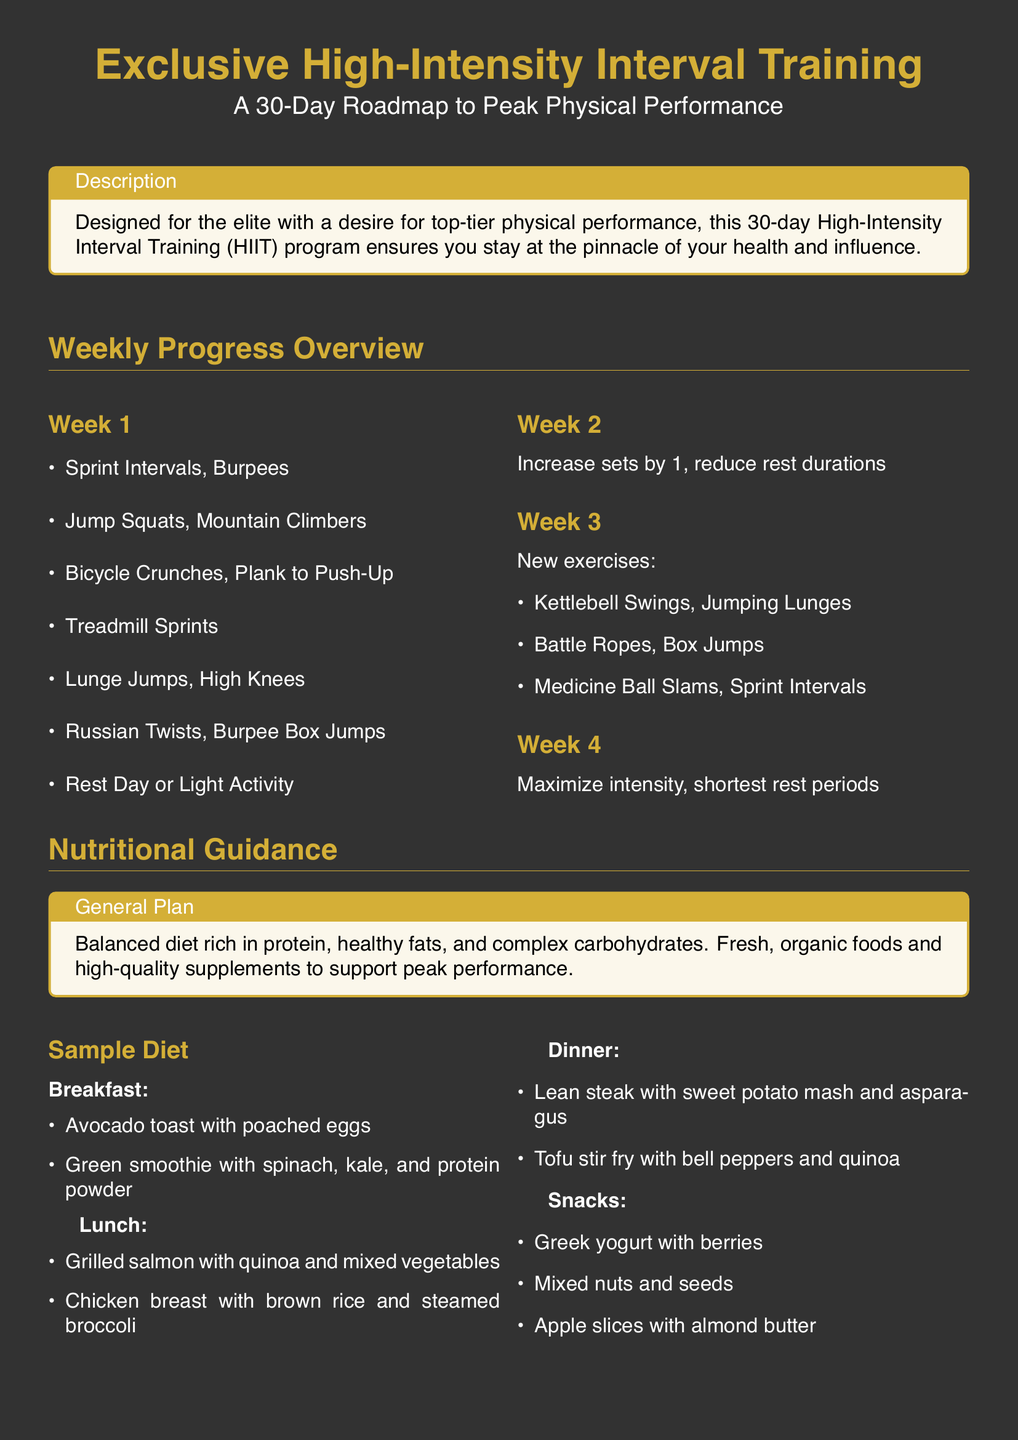What is the title of the program? The title of the program is prominently displayed at the beginning of the document, indicating its focus on high-intensity interval training.
Answer: Exclusive High-Intensity Interval Training How long is the program designed for? The document specifies the duration of the workout program in its introduction, indicating a clear timeframe for participants.
Answer: 30-Day What are the new exercises introduced in Week 3? The document lists specific new exercises included in Week 3 for variety and progression in the training program.
Answer: Kettlebell Swings, Jumping Lunges, Battle Ropes, Box Jumps, Medicine Ball Slams, Sprint Intervals How many liters of water should be consumed daily? The document includes advice on hydration, specifying the daily water intake necessary for optimal performance.
Answer: 3 liters What type of diet is recommended in the general plan? The nutritional guidance section of the document describes the overall dietary approach athletes should follow for peak performance.
Answer: Balanced diet rich in protein, healthy fats, and complex carbohydrates Which exercise appears on both Week 1 and Week 3 lists? The comparison of exercises in the weekly plans highlights repetitions and focuses within the program's structure.
Answer: Sprint Intervals What snack is suggested that includes yogurt? The document provides specific examples of snacks that align with the nutritional plan, including one that features yogurt as a primary ingredient.
Answer: Greek yogurt with berries What should be considered for tailoring the diet further? The document suggests a way for individuals to personalize their nutritional approach for better results.
Answer: Consulting a personal nutritionist What is the primary focus for recovery mentioned in the special notes? The special notes section emphasizes aspects related to recovery, indicating a necessary component for workout success.
Answer: Adequate sleep 